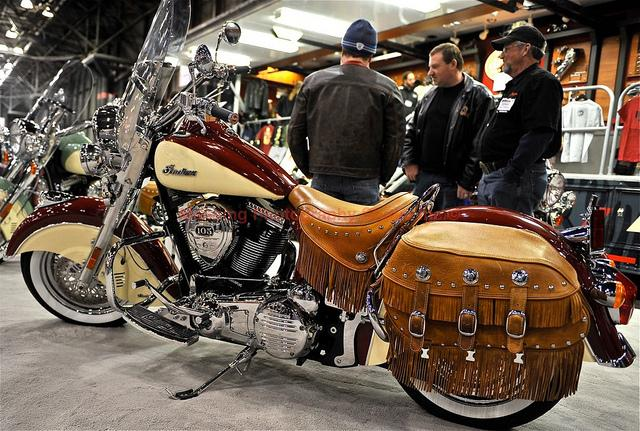What style is this bike decorated in? cowboy 